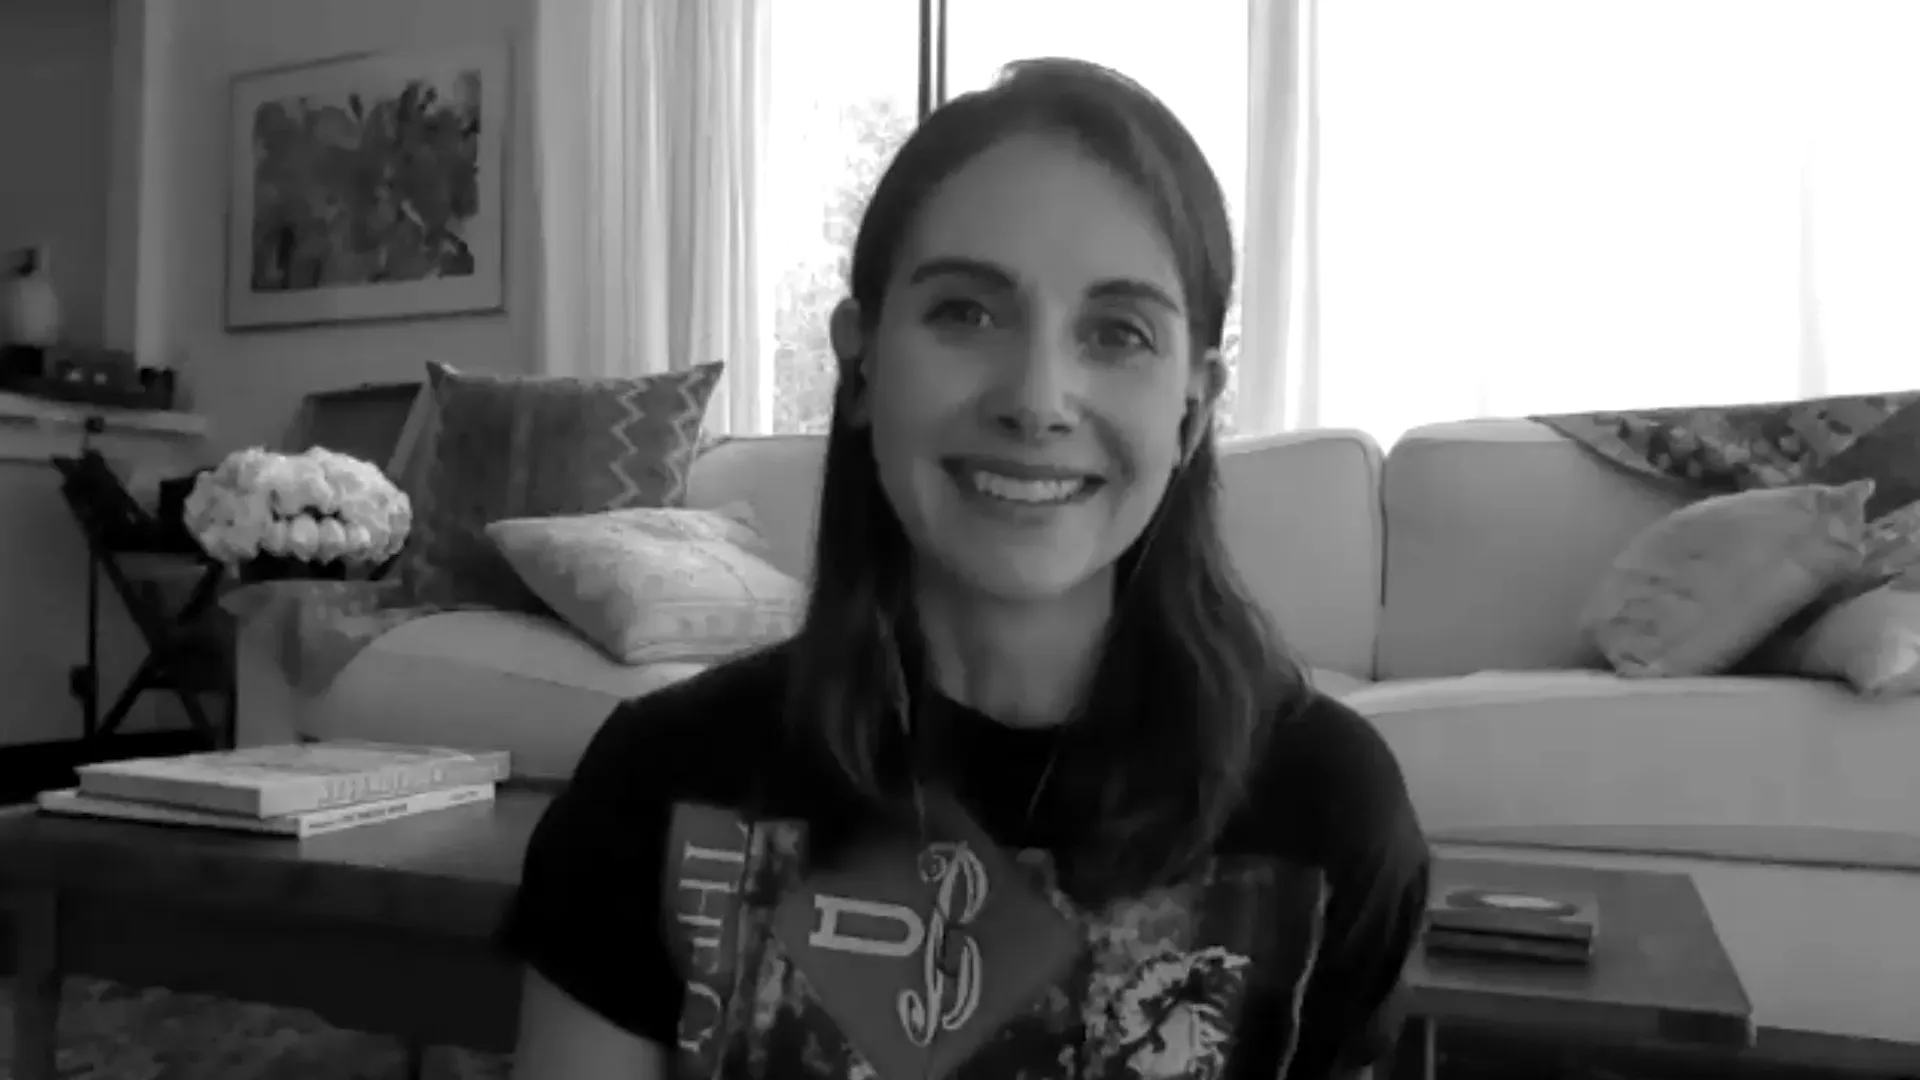Imagine a fantastic story happening in this living room. In this cozy living room, the woman’s seemingly ordinary day takes an extraordinary turn. As she reaches for a book on the coffee table, she discovers it is a magical tome that transports her into a mystical world. The room transforms into a portal filled with shimmering light, and suddenly she finds herself amid a grand adventure, navigating ancient realms and uncovering hidden secrets. Each return to her living room brings new artifacts and mystical elements that gradually intermingle with her everyday surroundings. That sounds interesting! What kind of artifacts does she bring back? She brings back a variety of fascinating artifacts: an ancient-looking compass that always points towards adventure, a glowing crystal providing endless light, and a set of scrolls written in a long-forgotten language. One artifact is particularly intriguing—a small, intricately carved box that, when opened, releases a holographic map that constantly changes, revealing new paths and secrets each time. 